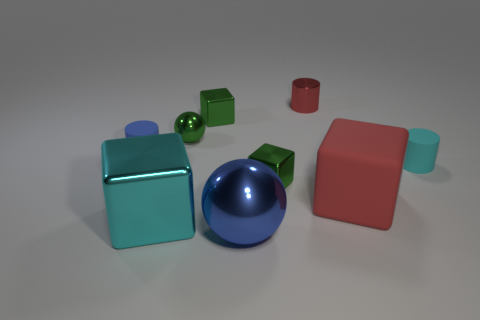Subtract all cylinders. How many objects are left? 6 Add 9 tiny blue objects. How many tiny blue objects exist? 10 Subtract 0 yellow cubes. How many objects are left? 9 Subtract all rubber cylinders. Subtract all tiny gray rubber balls. How many objects are left? 7 Add 2 tiny green metallic blocks. How many tiny green metallic blocks are left? 4 